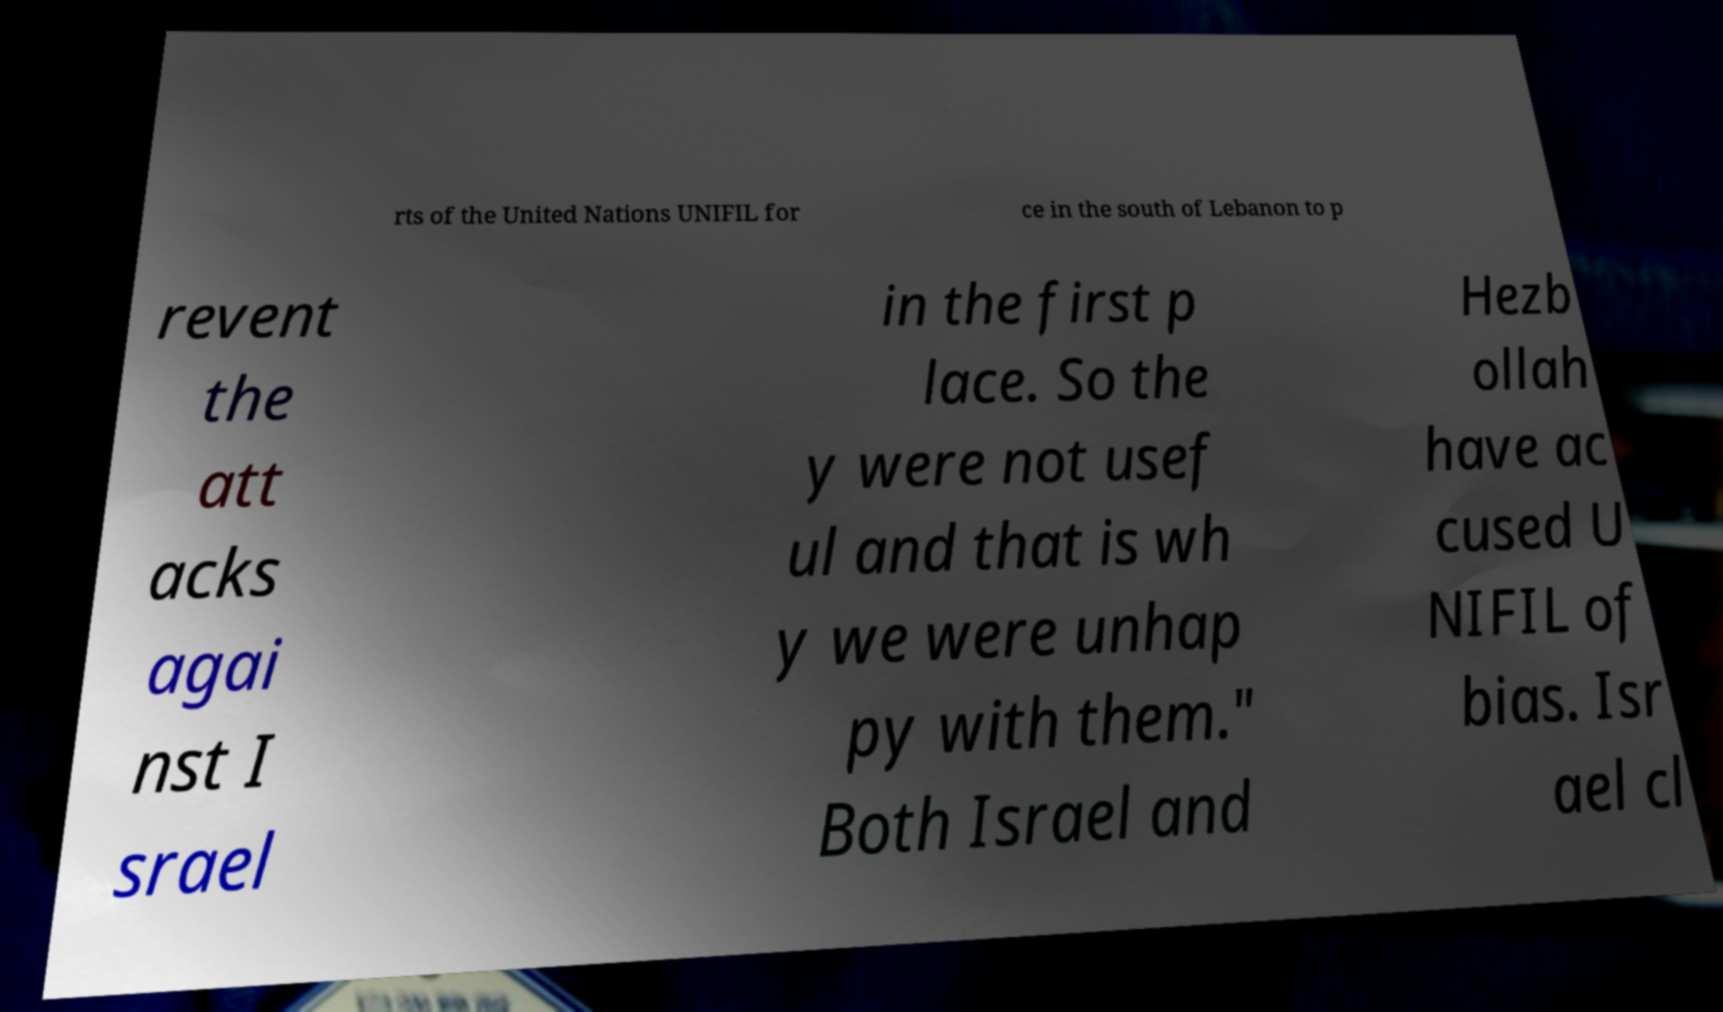What messages or text are displayed in this image? I need them in a readable, typed format. rts of the United Nations UNIFIL for ce in the south of Lebanon to p revent the att acks agai nst I srael in the first p lace. So the y were not usef ul and that is wh y we were unhap py with them." Both Israel and Hezb ollah have ac cused U NIFIL of bias. Isr ael cl 